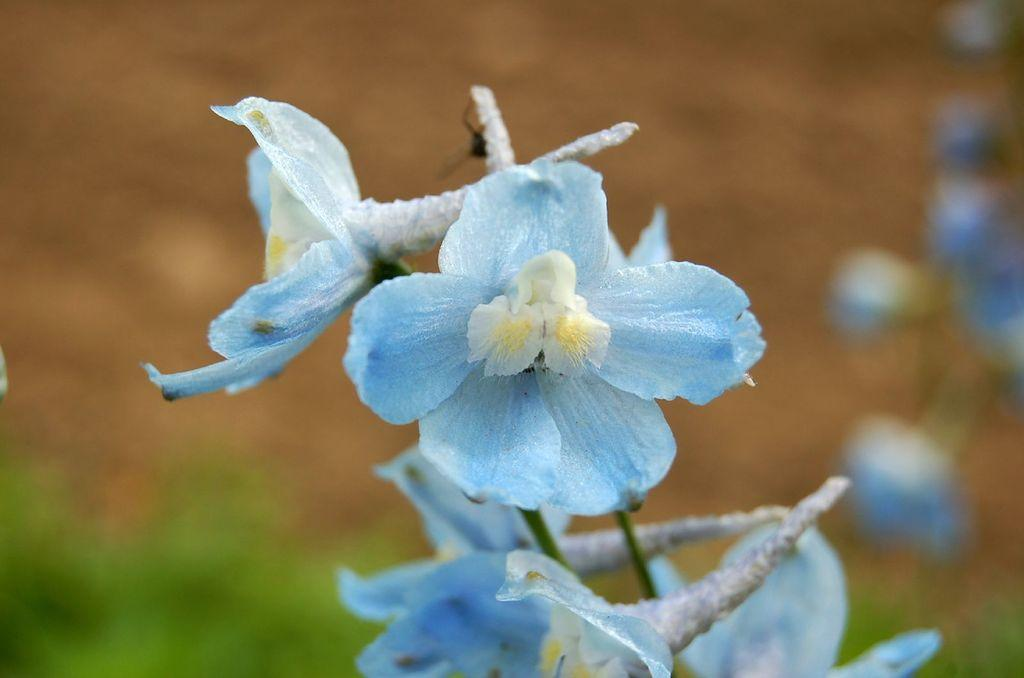What type of living organisms can be seen in the image? There are flowers in the image. Can you describe the background of the image? The background of the image is blurry. What company is responsible for the attention-grabbing play in the image? There is no company or play mentioned or depicted in the image, as it only features flowers and a blurry background. 